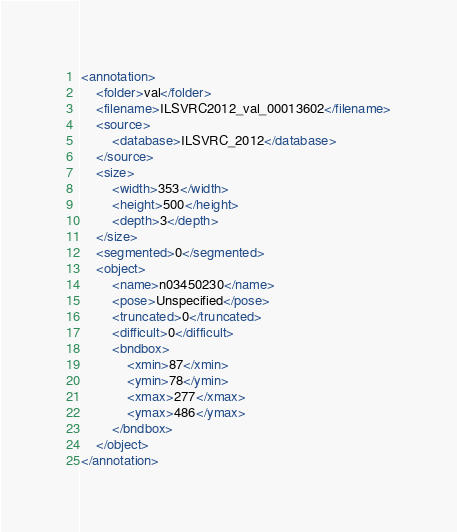Convert code to text. <code><loc_0><loc_0><loc_500><loc_500><_XML_><annotation>
	<folder>val</folder>
	<filename>ILSVRC2012_val_00013602</filename>
	<source>
		<database>ILSVRC_2012</database>
	</source>
	<size>
		<width>353</width>
		<height>500</height>
		<depth>3</depth>
	</size>
	<segmented>0</segmented>
	<object>
		<name>n03450230</name>
		<pose>Unspecified</pose>
		<truncated>0</truncated>
		<difficult>0</difficult>
		<bndbox>
			<xmin>87</xmin>
			<ymin>78</ymin>
			<xmax>277</xmax>
			<ymax>486</ymax>
		</bndbox>
	</object>
</annotation></code> 